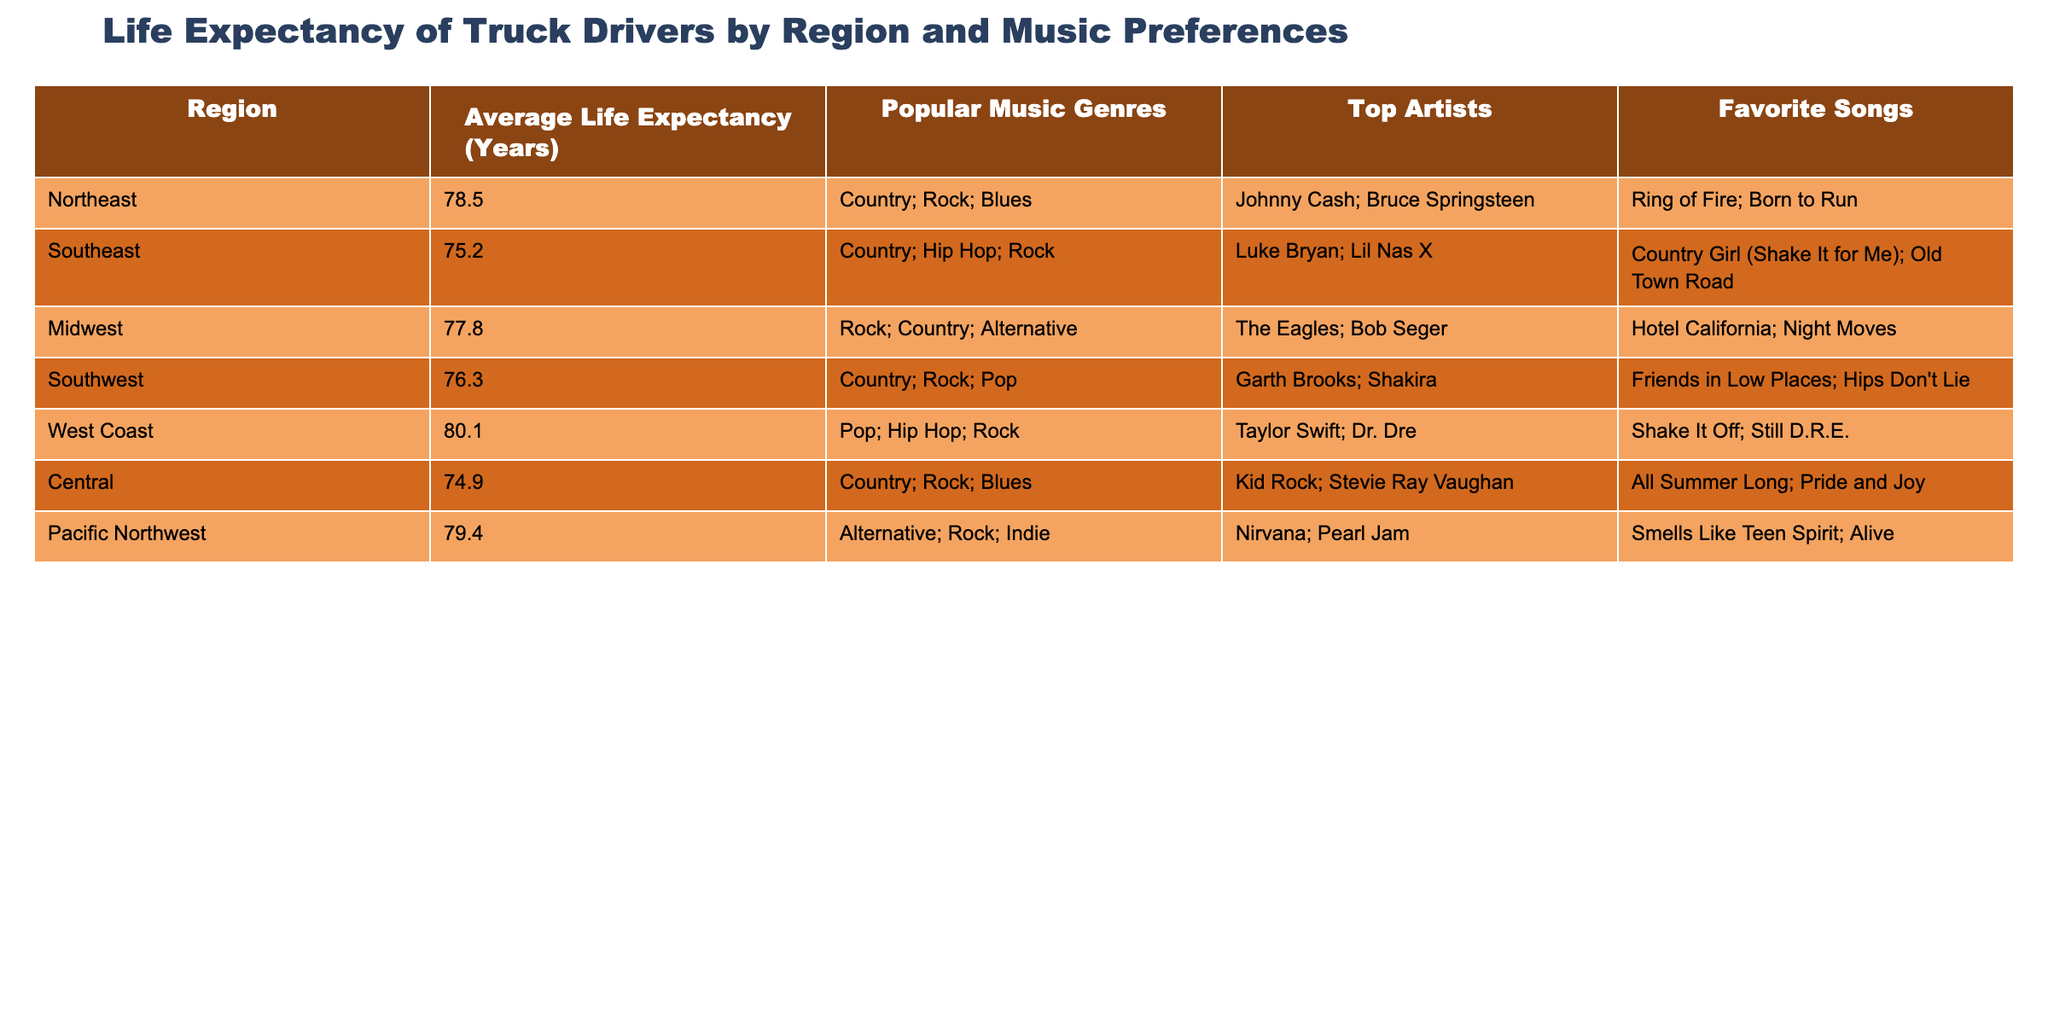What is the average life expectancy of truck drivers in the West Coast region? The table shows that the average life expectancy for the West Coast region is directly listed as 80.1 years.
Answer: 80.1 years Which region has the lowest average life expectancy? By comparing the life expectancy values, the Southeast region has the lowest average life expectancy of 75.2 years.
Answer: Southeast Is country music the most popular genre among truck drivers in the Northeast? The table indicates that the popular music genres in the Northeast include Country, Rock, and Blues. Since Country is listed first, we can infer that it is the most popular genre there.
Answer: Yes How many years does the average life expectancy of truck drivers in the Pacific Northwest exceed that of the Central region? The average life expectancy in the Pacific Northwest is 79.4 years, while in the Central region it is 74.9 years. The difference is 79.4 - 74.9 = 4.5 years.
Answer: 4.5 years What is the sum of the average life expectancy of truck drivers in the Midwest and Southwest regions? The average life expectancy in the Midwest is 77.8 years and in the Southwest is 76.3 years. Summing these gives 77.8 + 76.3 = 154.1 years.
Answer: 154.1 years Which two regions have the same popular music genre, and what is that genre? By examining the table, both the Northeast and Southwest regions have Country as a popular music genre.
Answer: Country Is there any region where the average life expectancy is above 78 years? Looking through the table, both the West Coast (80.1 years) and Pacific Northwest (79.4 years) have life expectancies above 78 years.
Answer: Yes Which top artist is associated with the favorite song "Shake It Off"? The table clearly shows that Taylor Swift is the top artist associated with the favorite song "Shake It Off."
Answer: Taylor Swift What is the average life expectancy of truck drivers across all regions represented in the table? To find the average, sum the life expectancies: (78.5 + 75.2 + 77.8 + 76.3 + 80.1 + 74.9 + 79.4) = 542.2 years. Divide by the number of regions, which is 7: 542.2 / 7 = 77.46 years.
Answer: 77.46 years 